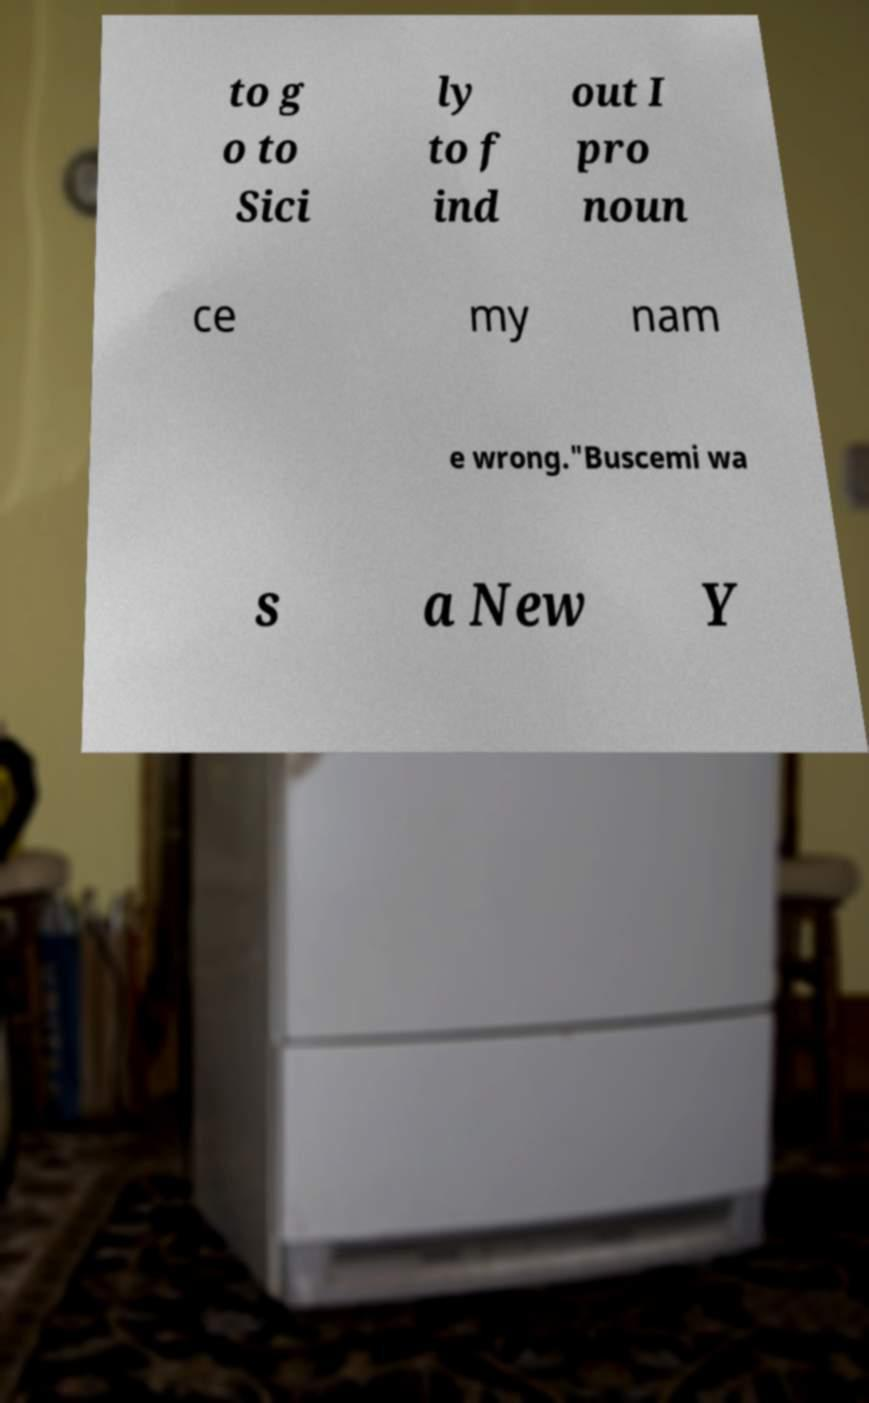For documentation purposes, I need the text within this image transcribed. Could you provide that? to g o to Sici ly to f ind out I pro noun ce my nam e wrong."Buscemi wa s a New Y 